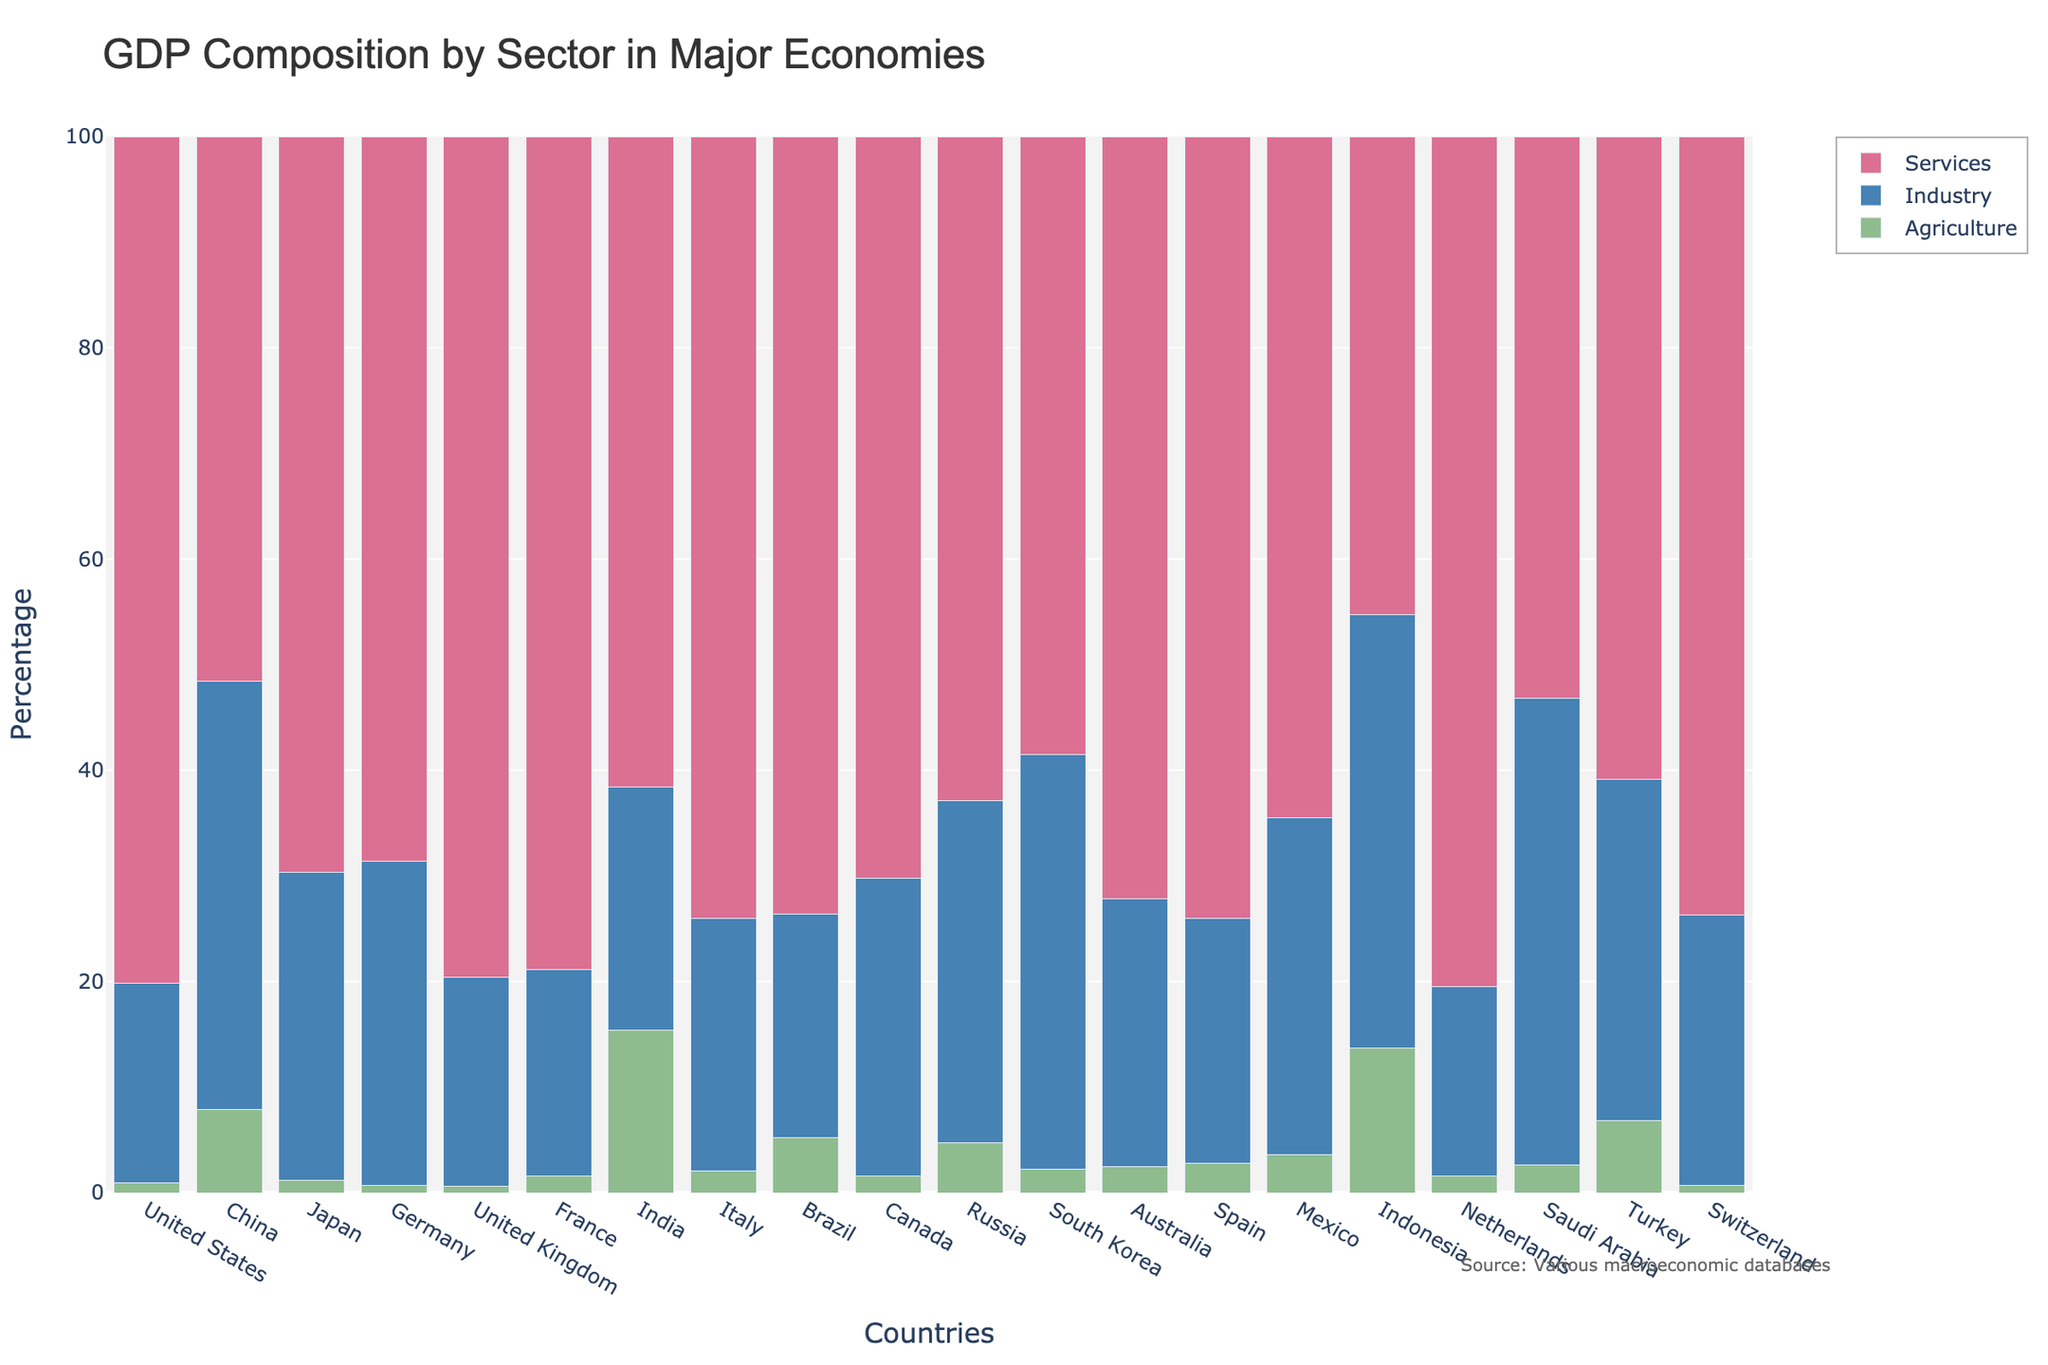Which country has the highest percentage of GDP from the agriculture sector? By examining the bar corresponding to the agriculture sector for each country, we can see which bar is the tallest. India has the tallest bar for agriculture, indicating the highest percentage.
Answer: India Which country has the smallest percentage of GDP from services? By examining the bar corresponding to the services sector for each country, we can see which bar is the shortest. Indonesia has the shortest bar for services, indicating the smallest percentage.
Answer: Indonesia How does the industry contribution to GDP in China compare to that in Germany? By comparing the height of the industry sector bars for China and Germany, we see that China's bar is significantly taller. This means China's industry contribution to GDP is higher than Germany's.
Answer: China > Germany In terms of services, which of the following countries have similar contributions: Italy, Spain, and Switzerland? By looking at the heights of the services sector bars for Italy, Spain, and Switzerland, we notice they are almost the same height. Thus, the contributions are similar.
Answer: Italy, Spain, and Switzerland What is the total percentage contribution to GDP from agriculture and industry in Turkey? Add the percentage of GDP from agriculture and industry in Turkey: 6.8 + 32.3 = 39.1.
Answer: 39.1 Which country has a higher percentage contribution from agriculture, Brazil or Mexico? By comparing the height of the agriculture sector bars for Brazil and Mexico, we see that Mexico's bar is a bit taller than Brazil's.
Answer: Mexico Which sector dominates the GDP composition in most countries? By observing the heights of the bars across all countries, the services sector bars are generally the tallest, indicating the highest contribution to GDP in most countries.
Answer: Services Compare the total GDP percentage contribution from agriculture and services in Australia to Canada. Which country has a higher combined percentage? For Australia, combine agriculture and services: 2.5 + 72.2 = 74.7. For Canada, combine agriculture and services: 1.6 + 70.2 = 71.8. Australia has a higher combined percentage.
Answer: Australia Which country has the closest percentage of GDP contribution between industry and services? By comparing the lengths of the industry and services sector bars for each country, Saudi Arabia has closely similar bar heights for industry and services (44.2 and 53.2, respectively).
Answer: Saudi Arabia 